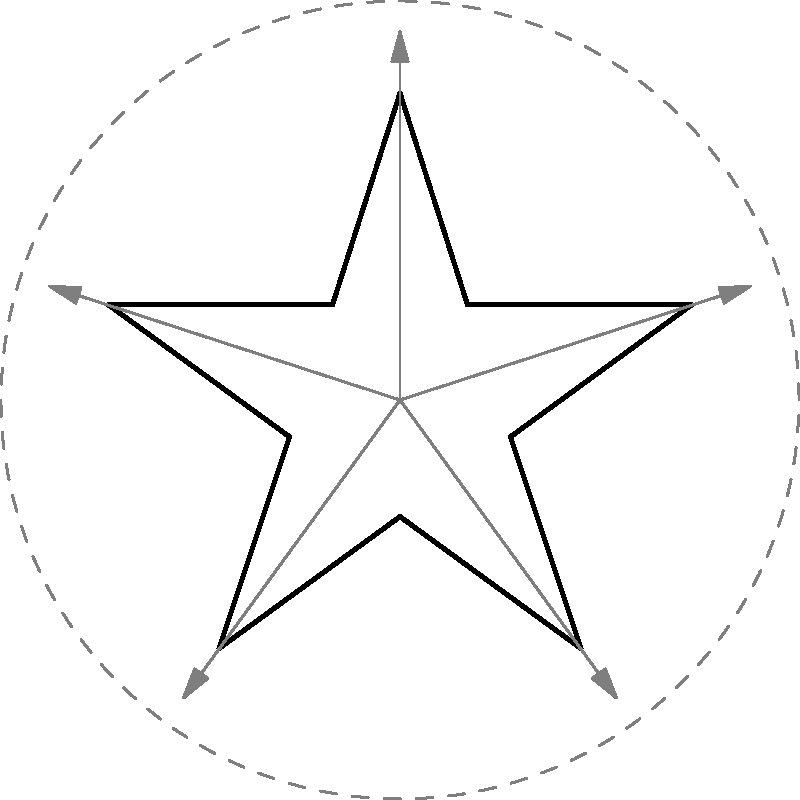Consider the star-shaped logo with rotational elements shown above. What is the order of the rotational symmetry group for this logo? To determine the order of the rotational symmetry group, we need to follow these steps:

1. Observe the number of distinct rotations that bring the star back to its original position.
2. Count the number of arrow indicators around the star.
3. Notice that the star has 5 points, which is consistent with the number of arrows.
4. Each rotation of $\frac{360°}{5} = 72°$ brings the star back to a position indistinguishable from its original state.
5. The possible rotations are:
   - 0° (identity)
   - 72°
   - 144°
   - 216°
   - 288°

6. Count the total number of these rotations, including the identity rotation.

Therefore, there are 5 elements in the rotational symmetry group of this star-shaped logo.
Answer: 5 